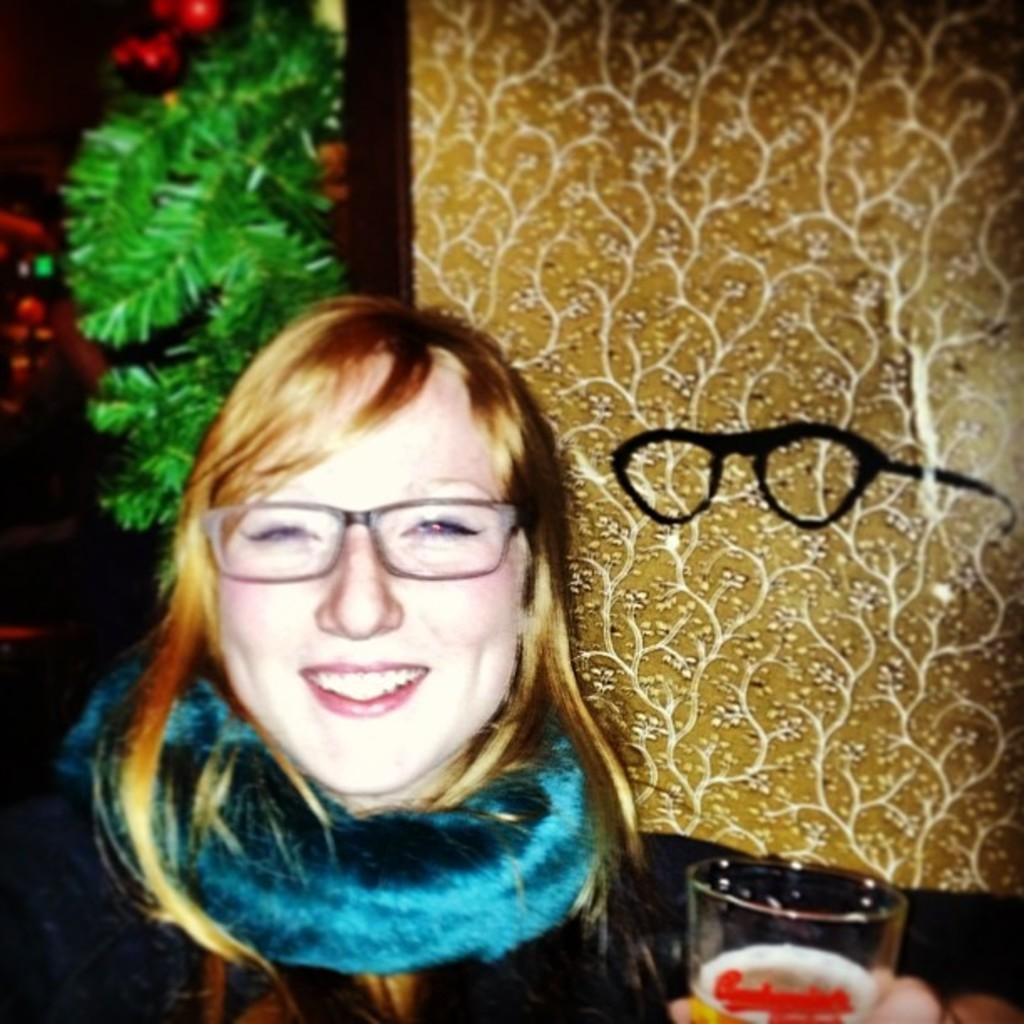Please provide a concise description of this image. In the center of the image, we can see a lady wearing glasses and a scarf and holding a glass with drink. In the background, there is a board and we can see streamers. 